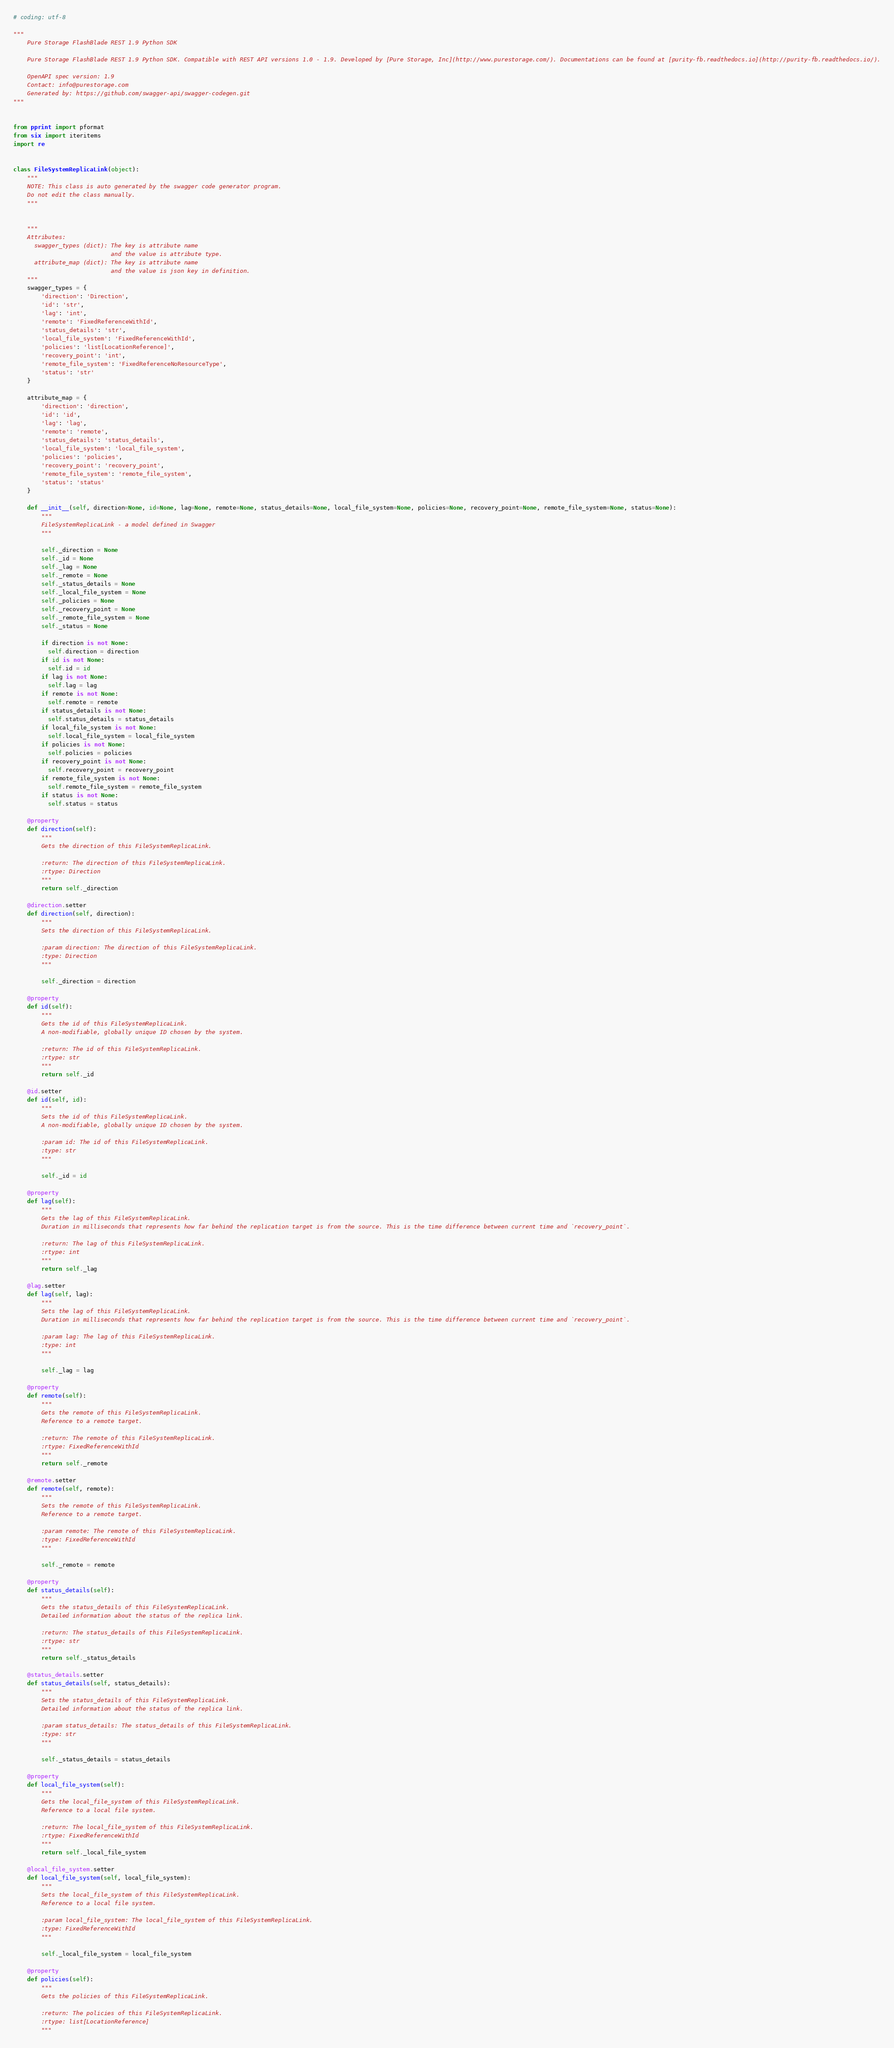Convert code to text. <code><loc_0><loc_0><loc_500><loc_500><_Python_># coding: utf-8

"""
    Pure Storage FlashBlade REST 1.9 Python SDK

    Pure Storage FlashBlade REST 1.9 Python SDK. Compatible with REST API versions 1.0 - 1.9. Developed by [Pure Storage, Inc](http://www.purestorage.com/). Documentations can be found at [purity-fb.readthedocs.io](http://purity-fb.readthedocs.io/).

    OpenAPI spec version: 1.9
    Contact: info@purestorage.com
    Generated by: https://github.com/swagger-api/swagger-codegen.git
"""


from pprint import pformat
from six import iteritems
import re


class FileSystemReplicaLink(object):
    """
    NOTE: This class is auto generated by the swagger code generator program.
    Do not edit the class manually.
    """


    """
    Attributes:
      swagger_types (dict): The key is attribute name
                            and the value is attribute type.
      attribute_map (dict): The key is attribute name
                            and the value is json key in definition.
    """
    swagger_types = {
        'direction': 'Direction',
        'id': 'str',
        'lag': 'int',
        'remote': 'FixedReferenceWithId',
        'status_details': 'str',
        'local_file_system': 'FixedReferenceWithId',
        'policies': 'list[LocationReference]',
        'recovery_point': 'int',
        'remote_file_system': 'FixedReferenceNoResourceType',
        'status': 'str'
    }

    attribute_map = {
        'direction': 'direction',
        'id': 'id',
        'lag': 'lag',
        'remote': 'remote',
        'status_details': 'status_details',
        'local_file_system': 'local_file_system',
        'policies': 'policies',
        'recovery_point': 'recovery_point',
        'remote_file_system': 'remote_file_system',
        'status': 'status'
    }

    def __init__(self, direction=None, id=None, lag=None, remote=None, status_details=None, local_file_system=None, policies=None, recovery_point=None, remote_file_system=None, status=None):
        """
        FileSystemReplicaLink - a model defined in Swagger
        """

        self._direction = None
        self._id = None
        self._lag = None
        self._remote = None
        self._status_details = None
        self._local_file_system = None
        self._policies = None
        self._recovery_point = None
        self._remote_file_system = None
        self._status = None

        if direction is not None:
          self.direction = direction
        if id is not None:
          self.id = id
        if lag is not None:
          self.lag = lag
        if remote is not None:
          self.remote = remote
        if status_details is not None:
          self.status_details = status_details
        if local_file_system is not None:
          self.local_file_system = local_file_system
        if policies is not None:
          self.policies = policies
        if recovery_point is not None:
          self.recovery_point = recovery_point
        if remote_file_system is not None:
          self.remote_file_system = remote_file_system
        if status is not None:
          self.status = status

    @property
    def direction(self):
        """
        Gets the direction of this FileSystemReplicaLink.

        :return: The direction of this FileSystemReplicaLink.
        :rtype: Direction
        """
        return self._direction

    @direction.setter
    def direction(self, direction):
        """
        Sets the direction of this FileSystemReplicaLink.

        :param direction: The direction of this FileSystemReplicaLink.
        :type: Direction
        """

        self._direction = direction

    @property
    def id(self):
        """
        Gets the id of this FileSystemReplicaLink.
        A non-modifiable, globally unique ID chosen by the system.

        :return: The id of this FileSystemReplicaLink.
        :rtype: str
        """
        return self._id

    @id.setter
    def id(self, id):
        """
        Sets the id of this FileSystemReplicaLink.
        A non-modifiable, globally unique ID chosen by the system.

        :param id: The id of this FileSystemReplicaLink.
        :type: str
        """

        self._id = id

    @property
    def lag(self):
        """
        Gets the lag of this FileSystemReplicaLink.
        Duration in milliseconds that represents how far behind the replication target is from the source. This is the time difference between current time and `recovery_point`.

        :return: The lag of this FileSystemReplicaLink.
        :rtype: int
        """
        return self._lag

    @lag.setter
    def lag(self, lag):
        """
        Sets the lag of this FileSystemReplicaLink.
        Duration in milliseconds that represents how far behind the replication target is from the source. This is the time difference between current time and `recovery_point`.

        :param lag: The lag of this FileSystemReplicaLink.
        :type: int
        """

        self._lag = lag

    @property
    def remote(self):
        """
        Gets the remote of this FileSystemReplicaLink.
        Reference to a remote target.

        :return: The remote of this FileSystemReplicaLink.
        :rtype: FixedReferenceWithId
        """
        return self._remote

    @remote.setter
    def remote(self, remote):
        """
        Sets the remote of this FileSystemReplicaLink.
        Reference to a remote target.

        :param remote: The remote of this FileSystemReplicaLink.
        :type: FixedReferenceWithId
        """

        self._remote = remote

    @property
    def status_details(self):
        """
        Gets the status_details of this FileSystemReplicaLink.
        Detailed information about the status of the replica link.

        :return: The status_details of this FileSystemReplicaLink.
        :rtype: str
        """
        return self._status_details

    @status_details.setter
    def status_details(self, status_details):
        """
        Sets the status_details of this FileSystemReplicaLink.
        Detailed information about the status of the replica link.

        :param status_details: The status_details of this FileSystemReplicaLink.
        :type: str
        """

        self._status_details = status_details

    @property
    def local_file_system(self):
        """
        Gets the local_file_system of this FileSystemReplicaLink.
        Reference to a local file system.

        :return: The local_file_system of this FileSystemReplicaLink.
        :rtype: FixedReferenceWithId
        """
        return self._local_file_system

    @local_file_system.setter
    def local_file_system(self, local_file_system):
        """
        Sets the local_file_system of this FileSystemReplicaLink.
        Reference to a local file system.

        :param local_file_system: The local_file_system of this FileSystemReplicaLink.
        :type: FixedReferenceWithId
        """

        self._local_file_system = local_file_system

    @property
    def policies(self):
        """
        Gets the policies of this FileSystemReplicaLink.

        :return: The policies of this FileSystemReplicaLink.
        :rtype: list[LocationReference]
        """</code> 